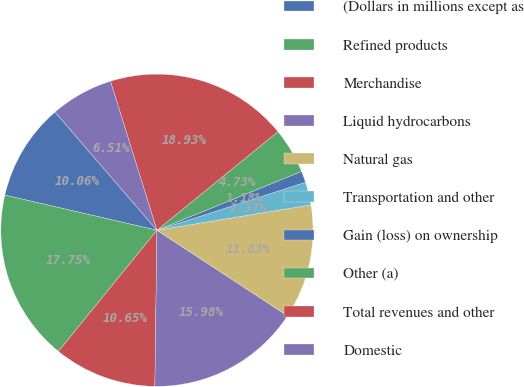Convert chart to OTSL. <chart><loc_0><loc_0><loc_500><loc_500><pie_chart><fcel>(Dollars in millions except as<fcel>Refined products<fcel>Merchandise<fcel>Liquid hydrocarbons<fcel>Natural gas<fcel>Transportation and other<fcel>Gain (loss) on ownership<fcel>Other (a)<fcel>Total revenues and other<fcel>Domestic<nl><fcel>10.06%<fcel>17.75%<fcel>10.65%<fcel>15.98%<fcel>11.83%<fcel>2.37%<fcel>1.18%<fcel>4.73%<fcel>18.93%<fcel>6.51%<nl></chart> 